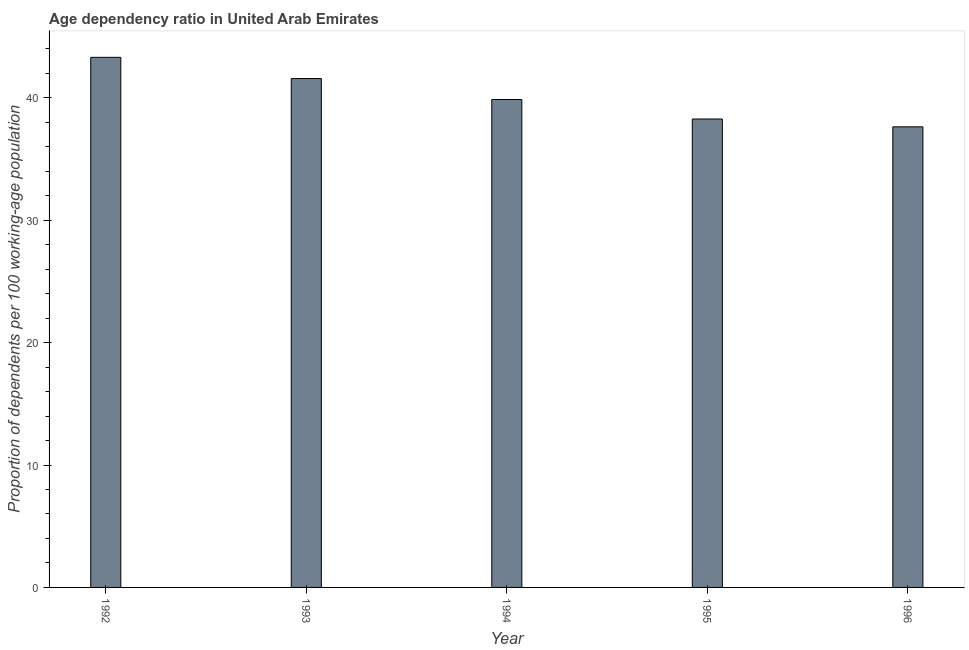Does the graph contain any zero values?
Ensure brevity in your answer.  No. What is the title of the graph?
Make the answer very short. Age dependency ratio in United Arab Emirates. What is the label or title of the X-axis?
Offer a very short reply. Year. What is the label or title of the Y-axis?
Give a very brief answer. Proportion of dependents per 100 working-age population. What is the age dependency ratio in 1995?
Your answer should be compact. 38.27. Across all years, what is the maximum age dependency ratio?
Your answer should be very brief. 43.31. Across all years, what is the minimum age dependency ratio?
Your response must be concise. 37.63. In which year was the age dependency ratio maximum?
Provide a succinct answer. 1992. What is the sum of the age dependency ratio?
Your answer should be compact. 200.63. What is the difference between the age dependency ratio in 1993 and 1994?
Your answer should be very brief. 1.71. What is the average age dependency ratio per year?
Offer a very short reply. 40.13. What is the median age dependency ratio?
Provide a short and direct response. 39.86. Do a majority of the years between 1995 and 1994 (inclusive) have age dependency ratio greater than 22 ?
Provide a short and direct response. No. What is the ratio of the age dependency ratio in 1992 to that in 1994?
Ensure brevity in your answer.  1.09. What is the difference between the highest and the second highest age dependency ratio?
Keep it short and to the point. 1.73. What is the difference between the highest and the lowest age dependency ratio?
Your response must be concise. 5.68. In how many years, is the age dependency ratio greater than the average age dependency ratio taken over all years?
Provide a succinct answer. 2. How many bars are there?
Ensure brevity in your answer.  5. Are all the bars in the graph horizontal?
Provide a short and direct response. No. How many years are there in the graph?
Keep it short and to the point. 5. What is the Proportion of dependents per 100 working-age population in 1992?
Offer a very short reply. 43.31. What is the Proportion of dependents per 100 working-age population of 1993?
Make the answer very short. 41.57. What is the Proportion of dependents per 100 working-age population of 1994?
Ensure brevity in your answer.  39.86. What is the Proportion of dependents per 100 working-age population of 1995?
Your response must be concise. 38.27. What is the Proportion of dependents per 100 working-age population of 1996?
Ensure brevity in your answer.  37.63. What is the difference between the Proportion of dependents per 100 working-age population in 1992 and 1993?
Provide a short and direct response. 1.73. What is the difference between the Proportion of dependents per 100 working-age population in 1992 and 1994?
Your response must be concise. 3.45. What is the difference between the Proportion of dependents per 100 working-age population in 1992 and 1995?
Your answer should be very brief. 5.04. What is the difference between the Proportion of dependents per 100 working-age population in 1992 and 1996?
Ensure brevity in your answer.  5.68. What is the difference between the Proportion of dependents per 100 working-age population in 1993 and 1994?
Your response must be concise. 1.71. What is the difference between the Proportion of dependents per 100 working-age population in 1993 and 1995?
Your response must be concise. 3.3. What is the difference between the Proportion of dependents per 100 working-age population in 1993 and 1996?
Offer a terse response. 3.95. What is the difference between the Proportion of dependents per 100 working-age population in 1994 and 1995?
Your answer should be very brief. 1.59. What is the difference between the Proportion of dependents per 100 working-age population in 1994 and 1996?
Offer a very short reply. 2.23. What is the difference between the Proportion of dependents per 100 working-age population in 1995 and 1996?
Provide a succinct answer. 0.64. What is the ratio of the Proportion of dependents per 100 working-age population in 1992 to that in 1993?
Ensure brevity in your answer.  1.04. What is the ratio of the Proportion of dependents per 100 working-age population in 1992 to that in 1994?
Your response must be concise. 1.09. What is the ratio of the Proportion of dependents per 100 working-age population in 1992 to that in 1995?
Provide a succinct answer. 1.13. What is the ratio of the Proportion of dependents per 100 working-age population in 1992 to that in 1996?
Make the answer very short. 1.15. What is the ratio of the Proportion of dependents per 100 working-age population in 1993 to that in 1994?
Give a very brief answer. 1.04. What is the ratio of the Proportion of dependents per 100 working-age population in 1993 to that in 1995?
Your response must be concise. 1.09. What is the ratio of the Proportion of dependents per 100 working-age population in 1993 to that in 1996?
Your answer should be compact. 1.1. What is the ratio of the Proportion of dependents per 100 working-age population in 1994 to that in 1995?
Offer a terse response. 1.04. What is the ratio of the Proportion of dependents per 100 working-age population in 1994 to that in 1996?
Your response must be concise. 1.06. What is the ratio of the Proportion of dependents per 100 working-age population in 1995 to that in 1996?
Your answer should be very brief. 1.02. 